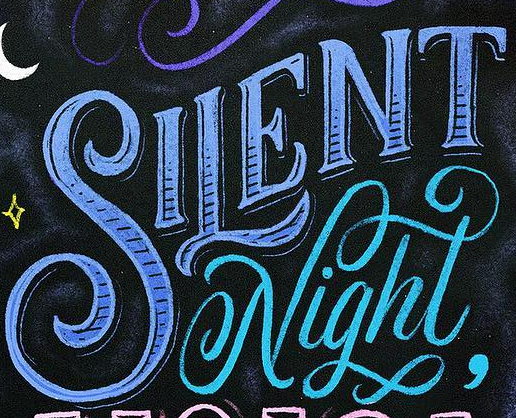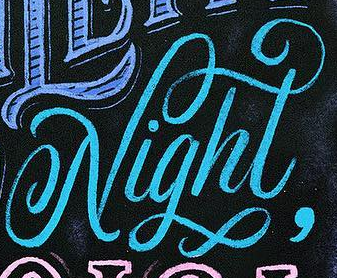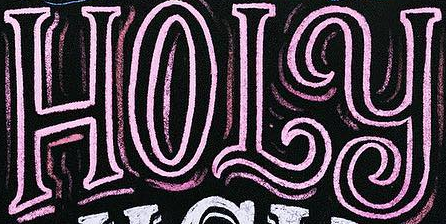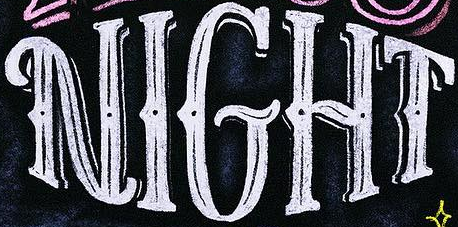What text appears in these images from left to right, separated by a semicolon? SILENT; Night; HOLY; NIGHT 